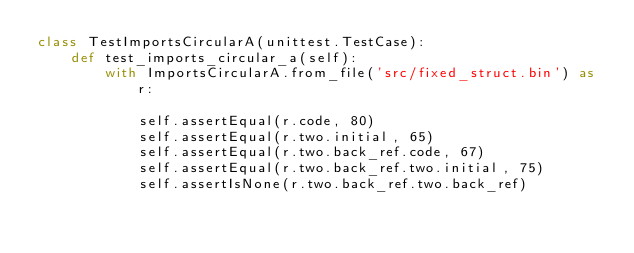Convert code to text. <code><loc_0><loc_0><loc_500><loc_500><_Python_>class TestImportsCircularA(unittest.TestCase):
    def test_imports_circular_a(self):
        with ImportsCircularA.from_file('src/fixed_struct.bin') as r:

            self.assertEqual(r.code, 80)
            self.assertEqual(r.two.initial, 65)
            self.assertEqual(r.two.back_ref.code, 67)
            self.assertEqual(r.two.back_ref.two.initial, 75)
            self.assertIsNone(r.two.back_ref.two.back_ref)
</code> 